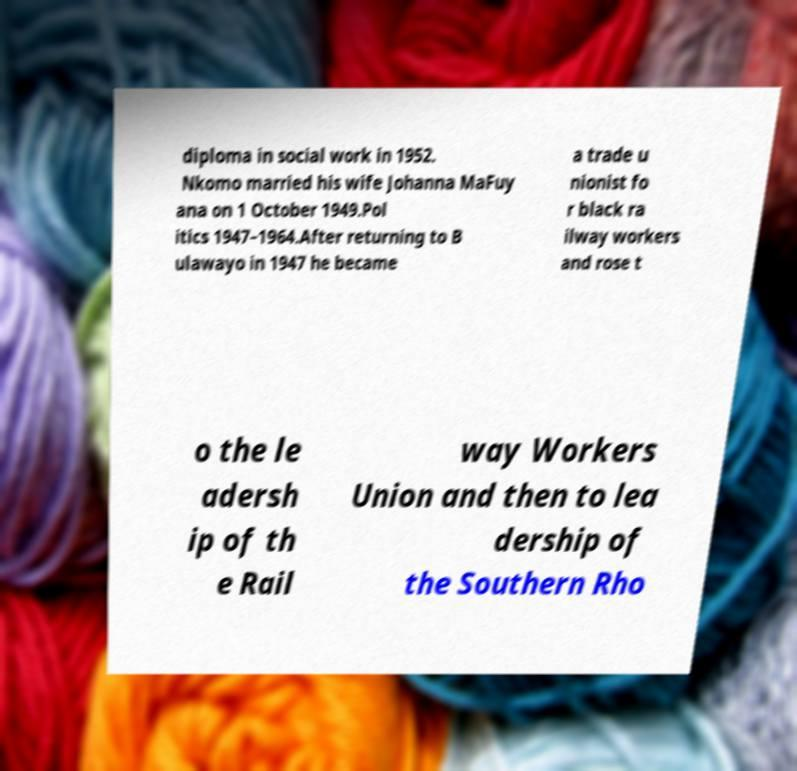Please read and relay the text visible in this image. What does it say? diploma in social work in 1952. Nkomo married his wife Johanna MaFuy ana on 1 October 1949.Pol itics 1947–1964.After returning to B ulawayo in 1947 he became a trade u nionist fo r black ra ilway workers and rose t o the le adersh ip of th e Rail way Workers Union and then to lea dership of the Southern Rho 